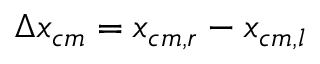<formula> <loc_0><loc_0><loc_500><loc_500>\Delta x _ { c m } = x _ { c m , r } - x _ { c m , l }</formula> 